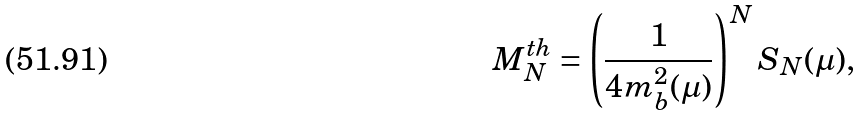<formula> <loc_0><loc_0><loc_500><loc_500>M _ { N } ^ { t h } = \left ( \frac { 1 } { 4 m _ { b } ^ { 2 } ( \mu ) } \right ) ^ { N } S _ { N } ( \mu ) ,</formula> 